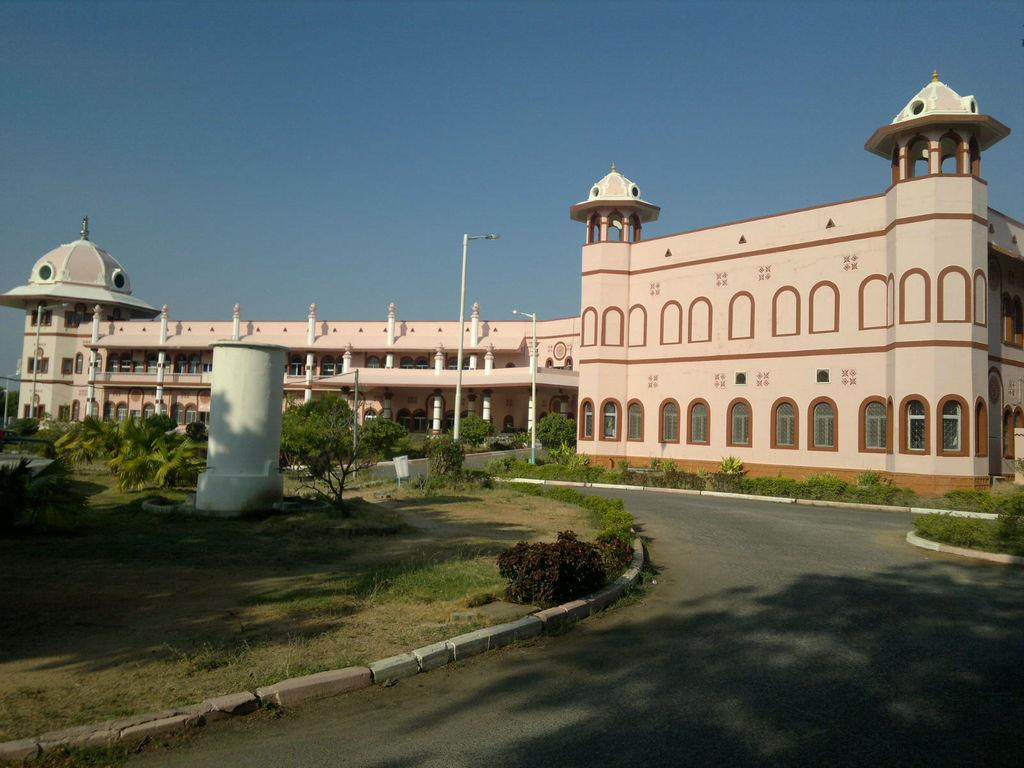What type of structure is present in the image? There is a building in the image. What type of vegetation can be seen in the image? There are plants, grass, and trees in the image. What are the poles in the image used for? The poles in the image are likely used to support the lights. What can be seen in the background of the image? The sky is visible in the background of the image. Where is the mailbox located in the image? There is no mailbox present in the image. What type of beef is being served in the image? There is no beef present in the image. 